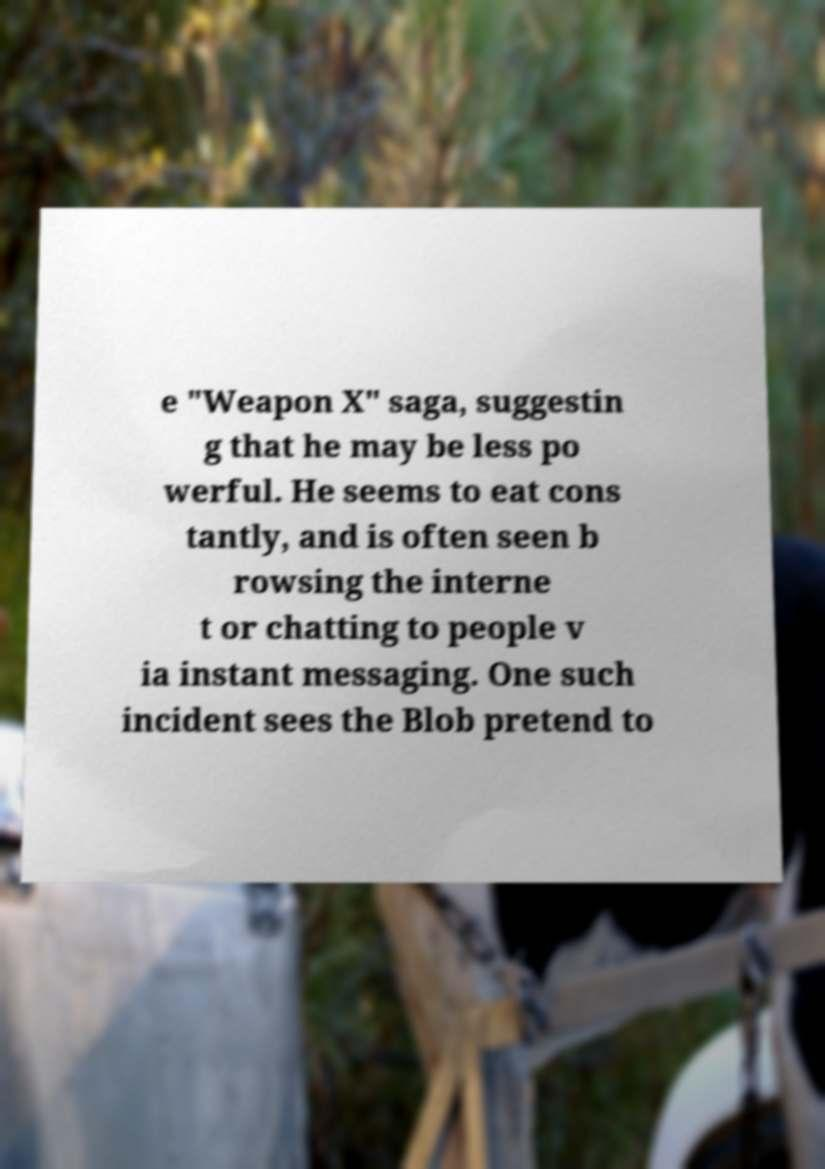Could you extract and type out the text from this image? e "Weapon X" saga, suggestin g that he may be less po werful. He seems to eat cons tantly, and is often seen b rowsing the interne t or chatting to people v ia instant messaging. One such incident sees the Blob pretend to 